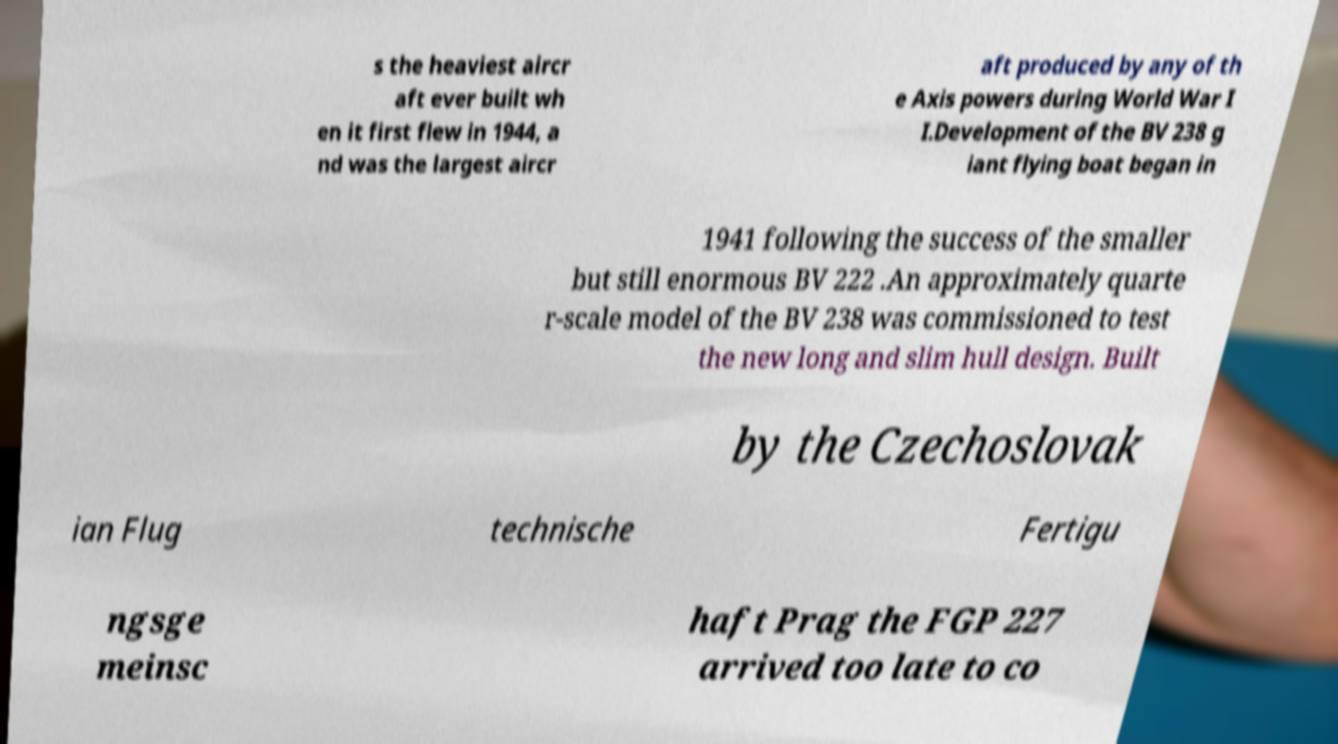Please identify and transcribe the text found in this image. s the heaviest aircr aft ever built wh en it first flew in 1944, a nd was the largest aircr aft produced by any of th e Axis powers during World War I I.Development of the BV 238 g iant flying boat began in 1941 following the success of the smaller but still enormous BV 222 .An approximately quarte r-scale model of the BV 238 was commissioned to test the new long and slim hull design. Built by the Czechoslovak ian Flug technische Fertigu ngsge meinsc haft Prag the FGP 227 arrived too late to co 